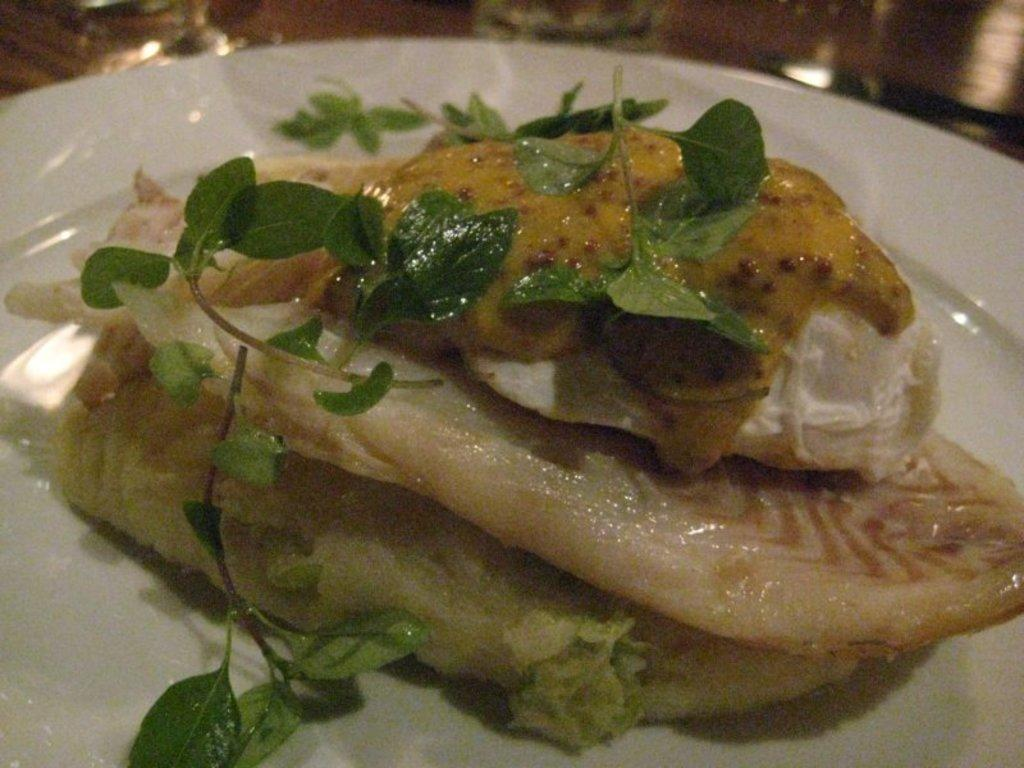What is the color of the plate in the image? The plate in the image is white. What is on the plate? There is food on the plate. What colors can be seen in the food? The food has white and brown colors. What type of vegetation is on the food? There are leaves on the food. How many boats are visible in the image? There are no boats present in the image. What is the current hour depicted in the image? The image does not show any time or hour. 